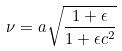Convert formula to latex. <formula><loc_0><loc_0><loc_500><loc_500>\nu = a \sqrt { \frac { 1 + \epsilon } { 1 + \epsilon c ^ { 2 } } }</formula> 